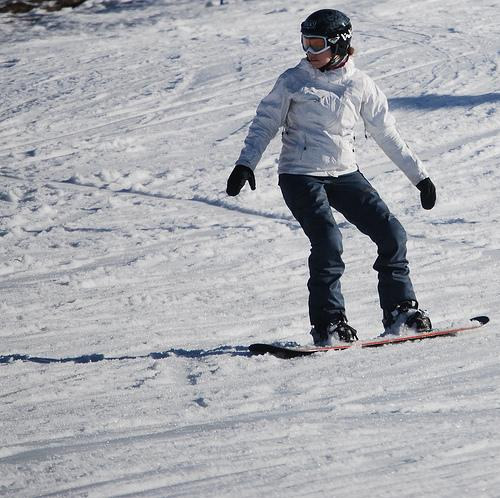Write a sentence describing the image as if it were a captured moment in a movie. In the film's exhilarating snowboarding scene, our fearless heroine glides effortlessly down the mountain, fully geared up for action. Describe the person's outfit in the image and how they are positioned in the scene. The woman wears a white jacket, black pants, gloves, helmet, and ski goggles as she snowboards down a mountain slope with snow tracks. Mention the snowboarding gear and accessories used by the person in the image. The snowboarder is equipped with a helmet, goggles, black gloves, black boots, and a red snowboard to glide through the snowy terrain. Describe the image by focusing on the snowy environment and the snowboarding action. Amidst a snow-covered mountain, a skilled female snowboarder weaves her path through the tracks left by others on a red snowboard. Provide an enthusiastic description of the person's adventure in the image. An excited woman carves her way down the snowy slopes, wearing all her safety gear, ready for an awesome day of snowboarding thrills! Describe the action in the image, emphasizing the athletic nature of the activity. Demonstrating impressive skill and athleticism, a woman navigates the snowy slopes on her red snowboard, geared up for the winter sport. Describe the image by commenting on the person's attire and its suitability for snowboarding. The snowboarder is dressed appropriately for the sport by wearing a white jacket, black ski pants, gloves, helmet, and goggles for safety and warmth. Imagine you're explaining the image to a child. Describe the main action happening in the picture. There's a lady riding a snowboard down a snowy hill, and she's wearing a helmet to protect her head and goggles for her eyes. In a poetic manner, describe the main subject and the environment in the image. A lone snow warrior descends the icy mountain, wrapped in white and black, slicing through snow's path with her trusty board. Provide a brief and straightforward description of what the person in the image is doing. A woman is snowboarding down a hill wearing a helmet and ski goggles. 